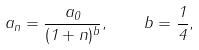Convert formula to latex. <formula><loc_0><loc_0><loc_500><loc_500>a _ { n } = \frac { a _ { 0 } } { ( 1 + n ) ^ { b } } , \quad b = \frac { 1 } { 4 } ,</formula> 